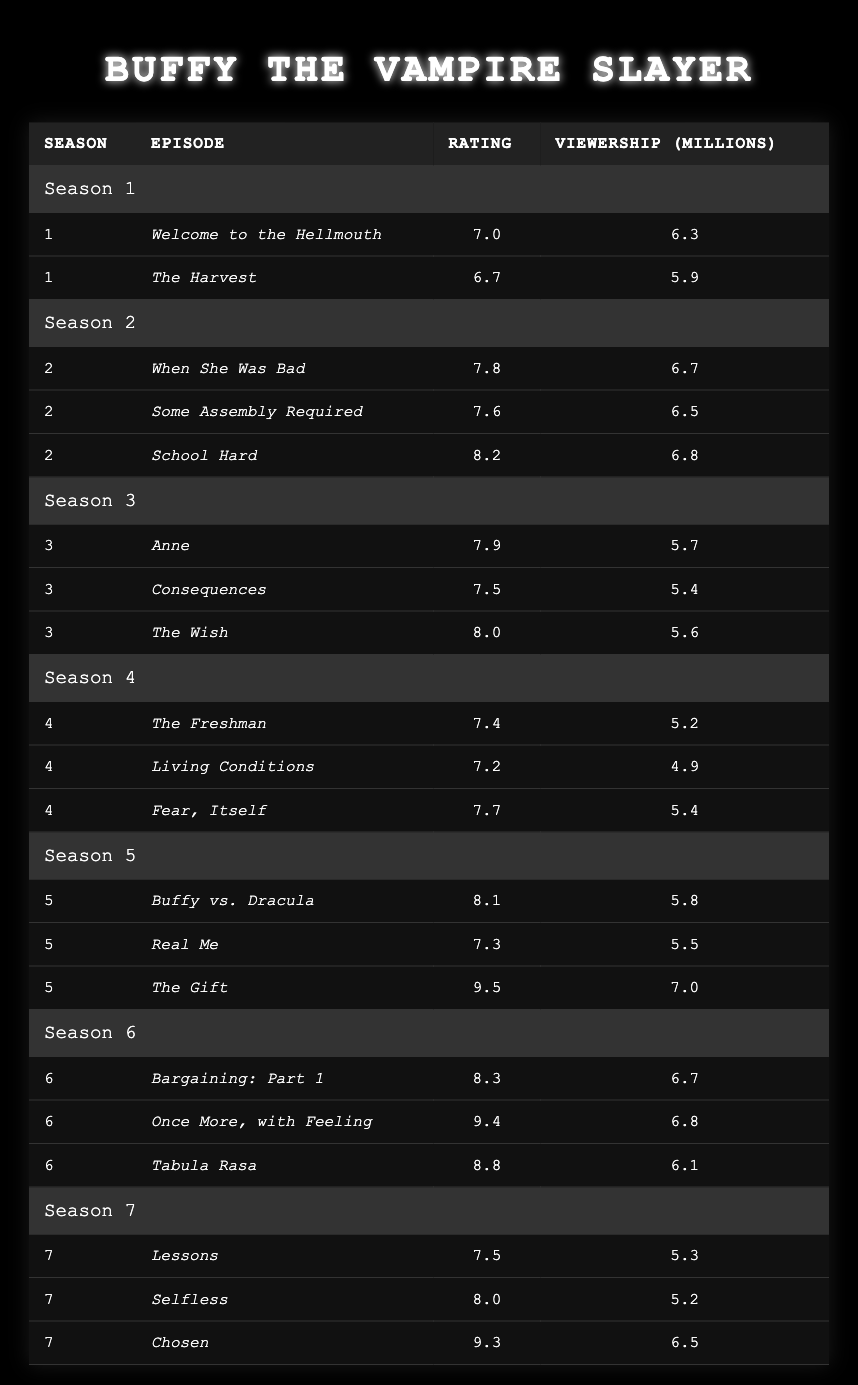What is the highest-rated episode in Season 5? Looking at the table for Season 5, "The Gift" has a rating of 9.5, which is higher than any other episode in that season.
Answer: 9.5 Which episode had the lowest viewership in Season 4? In Season 4, the episode "Living Conditions" has the lowest viewership at 4.9 million.
Answer: 4.9 million What is the average rating of all episodes in Season 6? The ratings for Season 6 are 8.3, 9.4, and 8.8. Calculating the average: (8.3 + 9.4 + 8.8) / 3 = 8.5.
Answer: 8.5 True or False: "Once More, with Feeling" had more viewers than "Fear, Itself." "Once More, with Feeling" has 6.8 million viewers, while "Fear, Itself" has 5.4 million, so it is true that it had more viewers.
Answer: True Which season had the episode with the highest viewership, and what was that viewership? Looking across all seasons, the episode "The Gift" from Season 5 had the highest viewership at 7.0 million.
Answer: Season 5, 7.0 million What is the combined viewership of all episodes in Season 3? The viewerships for Season 3 are 5.7, 5.4, and 5.6 million. Summing these gives: 5.7 + 5.4 + 5.6 = 16.7 million.
Answer: 16.7 million In which season did the episode "Chosen" air and what was its rating? "Chosen" aired in Season 7 and it has a rating of 9.3.
Answer: Season 7, 9.3 Which season had the most episodes with ratings above 8.0? Seasons 2, 5, and 6 have episodes with ratings above 8.0. Counting these, Season 2 has 1, Season 5 has 1, and Season 6 has 2, so Season 6 has the most episodes with ratings above 8.0.
Answer: Season 6 What is the difference in viewership between the highest and lowest-rated episodes in Season 1? The ratings for Season 1 are 7.0 and 6.7 with viewerships of 6.3 and 5.9 million, respectively. The difference in viewership is: 6.3 - 5.9 = 0.4 million.
Answer: 0.4 million How many episodes in Season 2 had ratings of 7.5 or higher? In Season 2, the episodes "When She Was Bad", "Some Assembly Required", and "School Hard" have ratings of 7.8, 7.6, and 8.2 respectively, totaling 3 episodes.
Answer: 3 episodes 